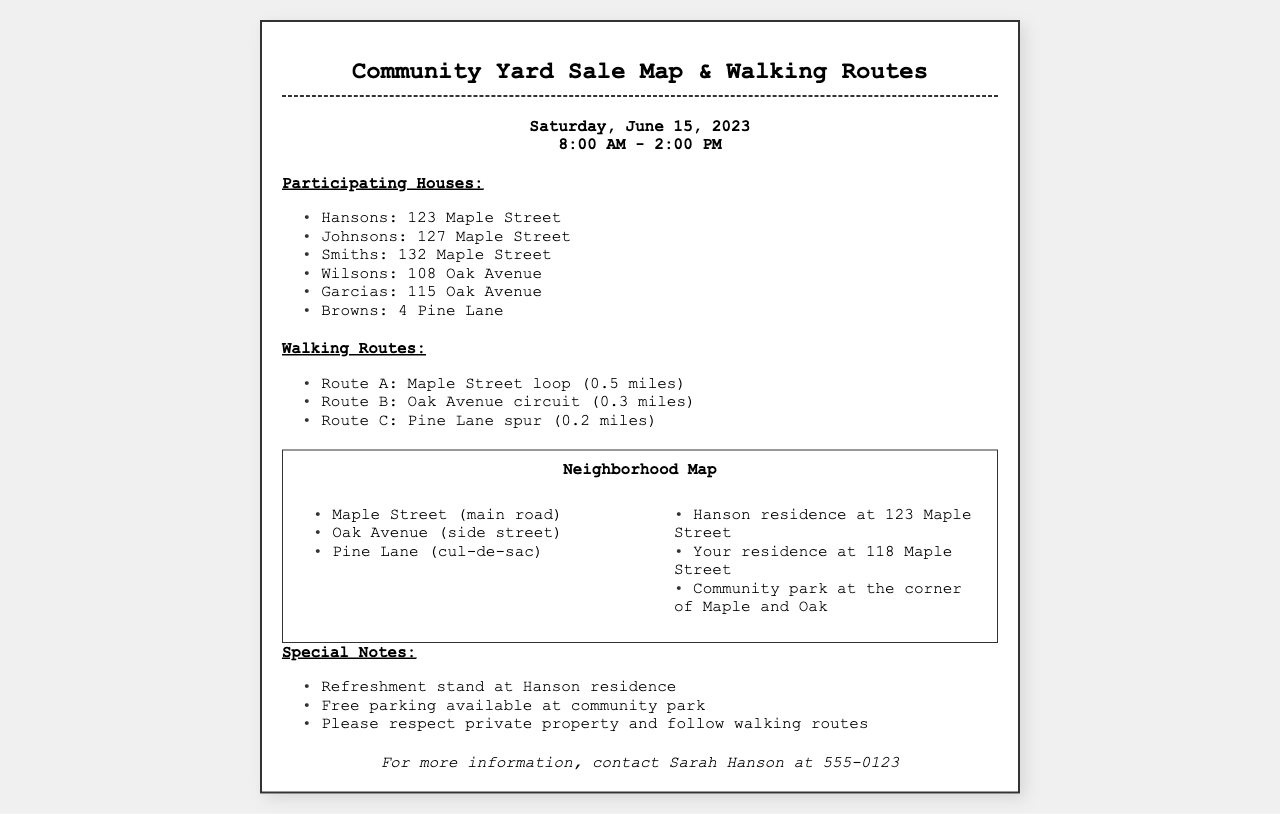what is the date of the yard sale? The date of the yard sale is mentioned in the document.
Answer: Saturday, June 15, 2023 what time does the yard sale start? The document states the starting time for the event.
Answer: 8:00 AM how many routes are listed for walking? The document provides the number of walking routes available.
Answer: 3 which house is hosting the refreshment stand? The refreshment stand's location is specified in the section about special notes.
Answer: Hanson residence what is the address of your house? The document includes your residence address.
Answer: 118 Maple Street how long is Route A? The length of Route A is provided in the walking routes section.
Answer: 0.5 miles which street is the community park located on? The document references the location of the community park in relation to streets.
Answer: corner of Maple and Oak what type of document is this? The format and content suggest the nature of this document.
Answer: Community Yard Sale Map & Walking Routes 